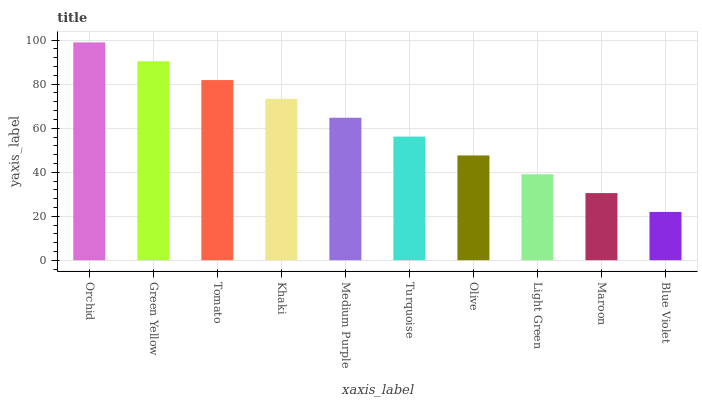Is Blue Violet the minimum?
Answer yes or no. Yes. Is Orchid the maximum?
Answer yes or no. Yes. Is Green Yellow the minimum?
Answer yes or no. No. Is Green Yellow the maximum?
Answer yes or no. No. Is Orchid greater than Green Yellow?
Answer yes or no. Yes. Is Green Yellow less than Orchid?
Answer yes or no. Yes. Is Green Yellow greater than Orchid?
Answer yes or no. No. Is Orchid less than Green Yellow?
Answer yes or no. No. Is Medium Purple the high median?
Answer yes or no. Yes. Is Turquoise the low median?
Answer yes or no. Yes. Is Green Yellow the high median?
Answer yes or no. No. Is Light Green the low median?
Answer yes or no. No. 